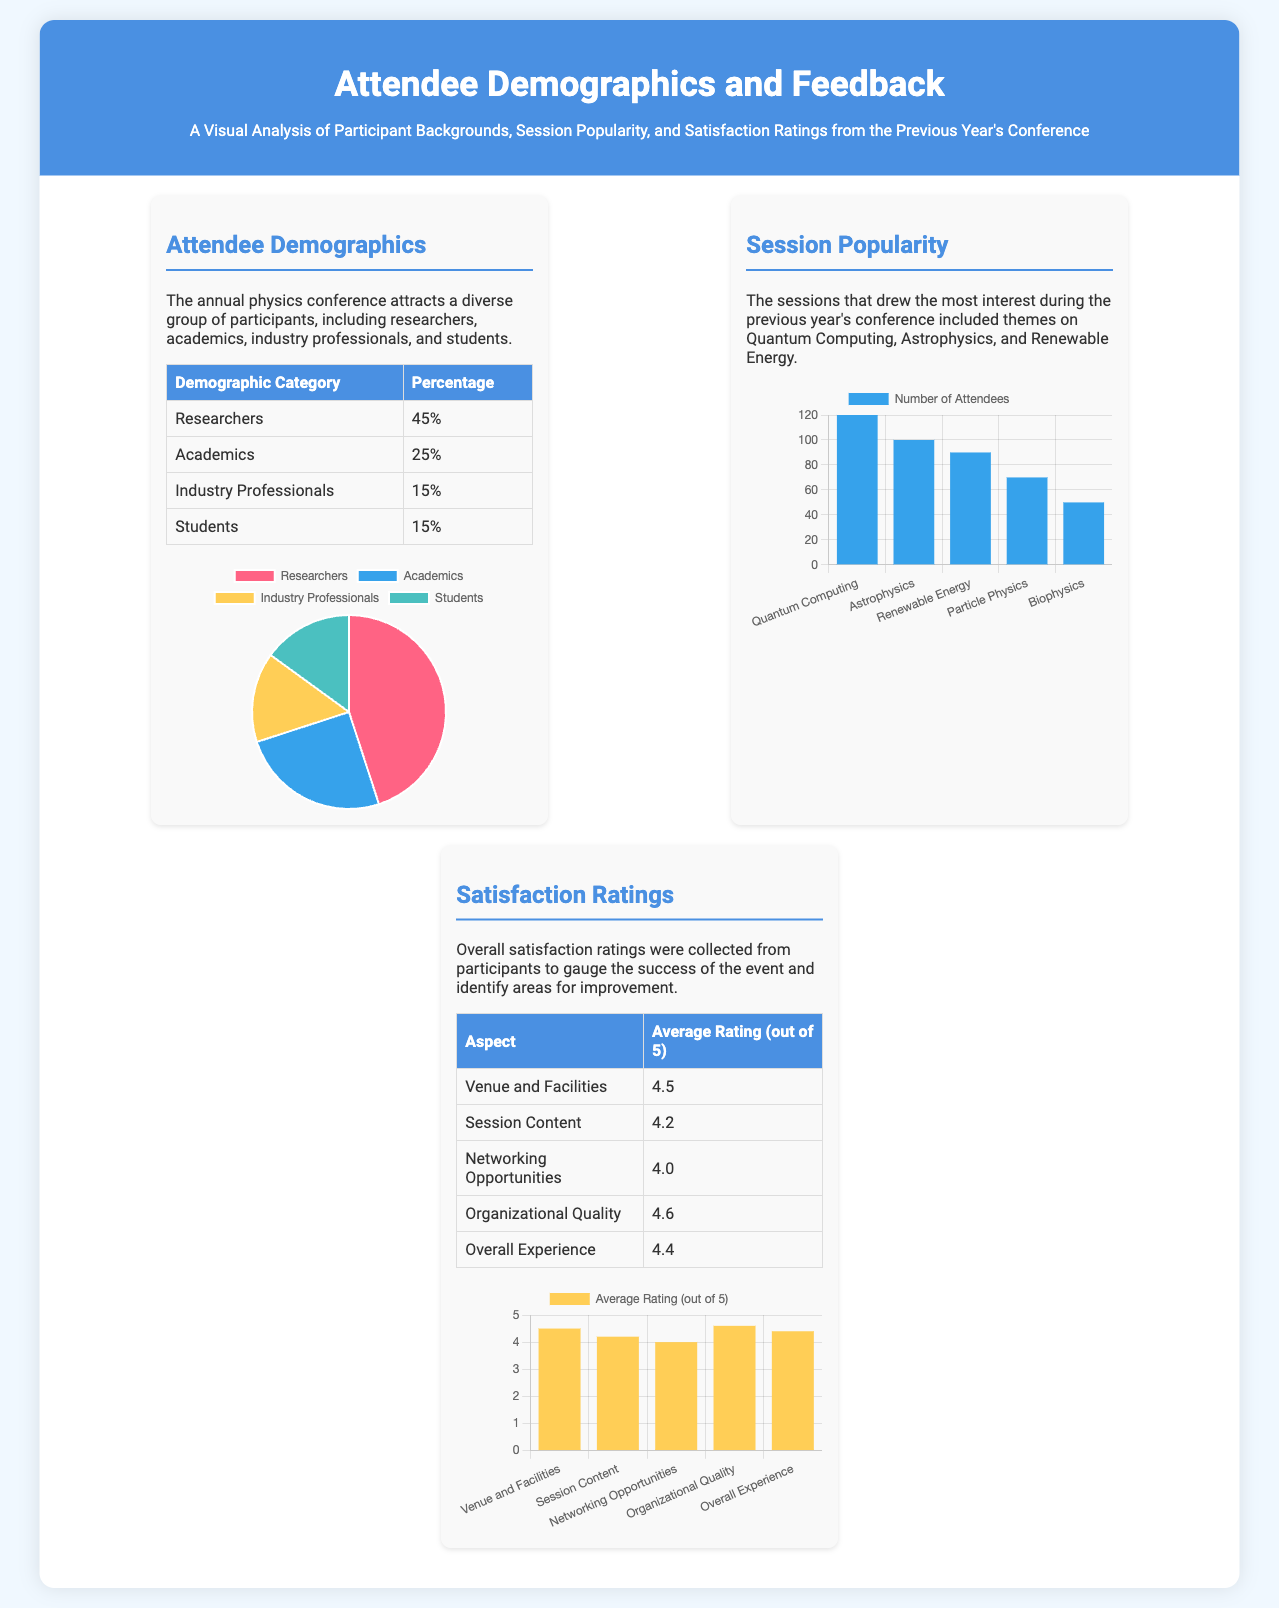What percentage of attendees were researchers? The document states that 45% of attendees were researchers.
Answer: 45% What was the average rating for "Networking Opportunities"? The average rating for "Networking Opportunities" is shown as 4.0 in the satisfaction ratings table.
Answer: 4.0 Which session had the highest number of attendees? The popularity chart indicates that "Quantum Computing" had the highest number with 120 attendees.
Answer: Quantum Computing What is the percentage of industry professionals attending? The demographics section indicates that the percentage of industry professionals is 15%.
Answer: 15% What was the overall satisfaction rating? According to the satisfaction ratings, the overall experience was rated 4.4 out of 5.
Answer: 4.4 How many attendees were there for the "Renewable Energy" session? The document mentions that there were 90 attendees for the "Renewable Energy" session.
Answer: 90 What demographic category had the lowest percentage? The demographic table shows that both "Industry Professionals" and "Students" had the lowest percentage at 15%.
Answer: Industry Professionals and Students How is the satisfaction rating for "Organizational Quality"? The table specifies that "Organizational Quality" received an average rating of 4.6 out of 5.
Answer: 4.6 What type of document is this? The format and content focus on attendee demographics, session popularity, and feedback, indicating it is a poster.
Answer: Poster 